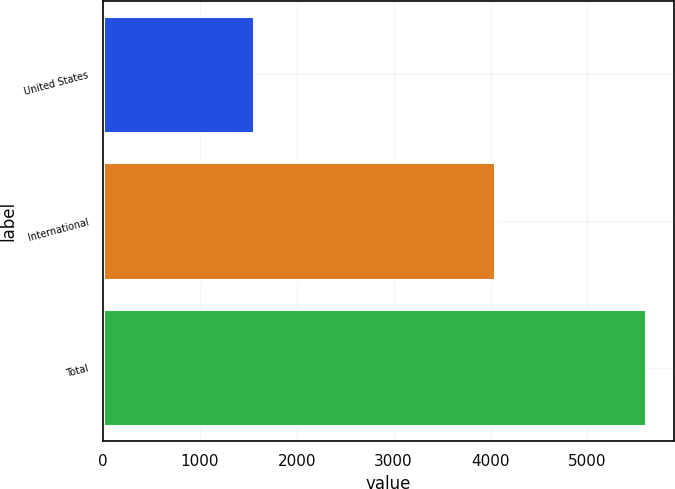<chart> <loc_0><loc_0><loc_500><loc_500><bar_chart><fcel>United States<fcel>International<fcel>Total<nl><fcel>1564.6<fcel>4042.6<fcel>5607.2<nl></chart> 